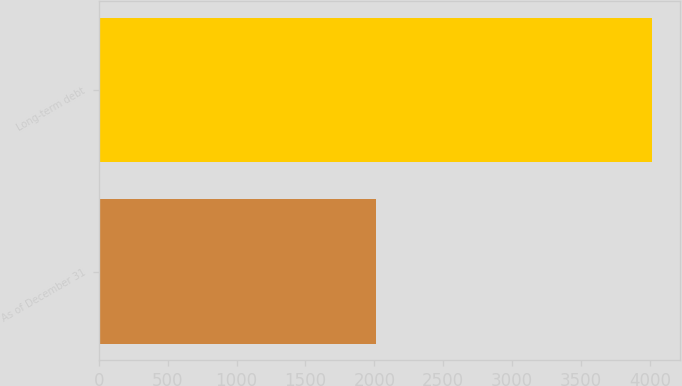Convert chart. <chart><loc_0><loc_0><loc_500><loc_500><bar_chart><fcel>As of December 31<fcel>Long-term debt<nl><fcel>2010<fcel>4014<nl></chart> 